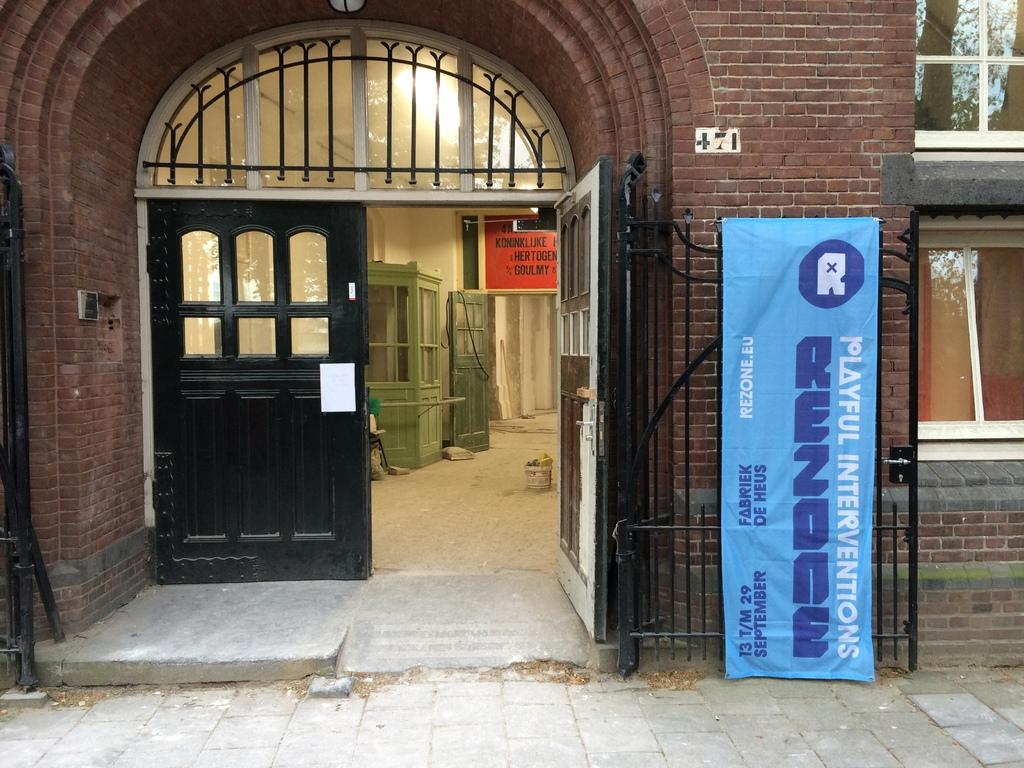What is on the gate in the image? There is a banner on the gate. What type of structure is visible in the image? There is a building in the image. What architectural features can be seen on the building? There are doors, windows, and a wall visible on the building. Are there any interior features visible in the image? Yes, there is a door, a board, and a booth inside the building. What is on the floor inside the building? There are objects on the floor inside the building. Where is the stage located in the image? There is no stage present in the image. What type of experience can be gained from the banner on the gate? The banner on the gate does not convey any specific experience; it is simply an object in the image. 